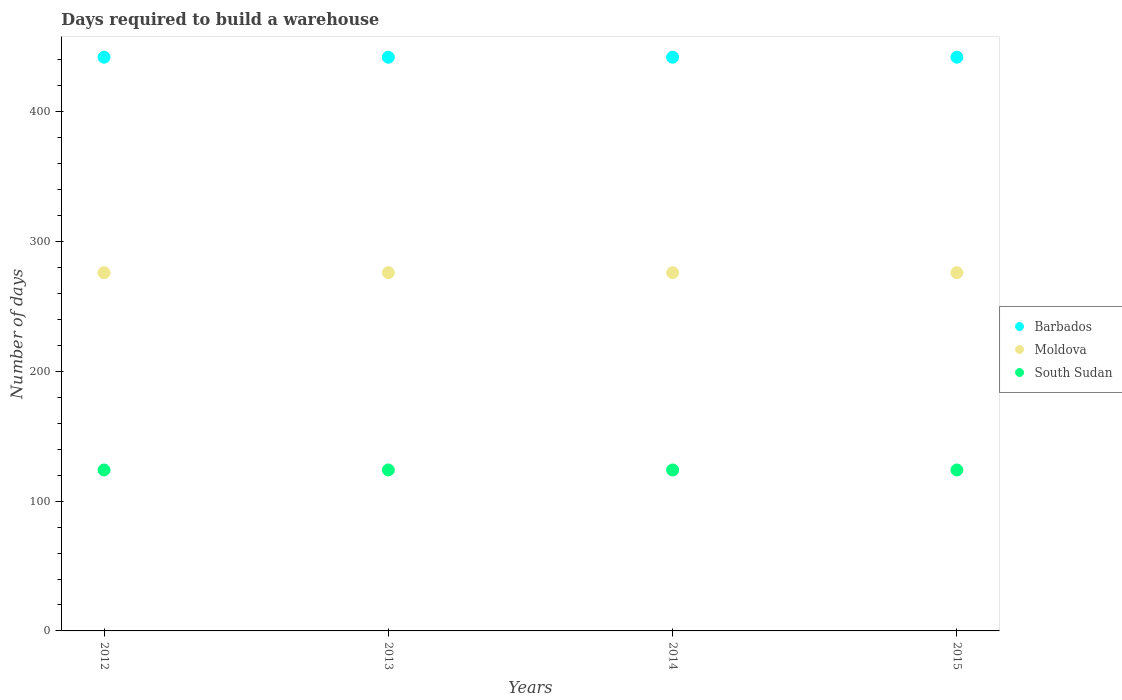What is the days required to build a warehouse in in South Sudan in 2013?
Provide a short and direct response. 124. Across all years, what is the maximum days required to build a warehouse in in Barbados?
Your answer should be very brief. 442. Across all years, what is the minimum days required to build a warehouse in in South Sudan?
Your response must be concise. 124. In which year was the days required to build a warehouse in in Barbados minimum?
Offer a terse response. 2012. What is the total days required to build a warehouse in in South Sudan in the graph?
Give a very brief answer. 496. What is the difference between the days required to build a warehouse in in Barbados in 2012 and that in 2014?
Make the answer very short. 0. What is the difference between the days required to build a warehouse in in Barbados in 2013 and the days required to build a warehouse in in Moldova in 2014?
Ensure brevity in your answer.  166. What is the average days required to build a warehouse in in Moldova per year?
Your answer should be very brief. 276. In the year 2012, what is the difference between the days required to build a warehouse in in South Sudan and days required to build a warehouse in in Moldova?
Make the answer very short. -152. In how many years, is the days required to build a warehouse in in South Sudan greater than 80 days?
Offer a terse response. 4. What is the ratio of the days required to build a warehouse in in Moldova in 2012 to that in 2014?
Offer a terse response. 1. Is the days required to build a warehouse in in Barbados in 2012 less than that in 2015?
Your answer should be compact. No. What is the difference between the highest and the second highest days required to build a warehouse in in Moldova?
Provide a short and direct response. 0. Is it the case that in every year, the sum of the days required to build a warehouse in in South Sudan and days required to build a warehouse in in Barbados  is greater than the days required to build a warehouse in in Moldova?
Make the answer very short. Yes. Is the days required to build a warehouse in in South Sudan strictly greater than the days required to build a warehouse in in Barbados over the years?
Keep it short and to the point. No. What is the difference between two consecutive major ticks on the Y-axis?
Offer a very short reply. 100. Are the values on the major ticks of Y-axis written in scientific E-notation?
Offer a very short reply. No. Where does the legend appear in the graph?
Ensure brevity in your answer.  Center right. What is the title of the graph?
Make the answer very short. Days required to build a warehouse. What is the label or title of the X-axis?
Your answer should be compact. Years. What is the label or title of the Y-axis?
Your answer should be compact. Number of days. What is the Number of days in Barbados in 2012?
Your answer should be compact. 442. What is the Number of days of Moldova in 2012?
Provide a short and direct response. 276. What is the Number of days of South Sudan in 2012?
Your answer should be compact. 124. What is the Number of days of Barbados in 2013?
Your response must be concise. 442. What is the Number of days of Moldova in 2013?
Your answer should be very brief. 276. What is the Number of days of South Sudan in 2013?
Provide a succinct answer. 124. What is the Number of days of Barbados in 2014?
Provide a short and direct response. 442. What is the Number of days of Moldova in 2014?
Make the answer very short. 276. What is the Number of days in South Sudan in 2014?
Give a very brief answer. 124. What is the Number of days in Barbados in 2015?
Your answer should be very brief. 442. What is the Number of days in Moldova in 2015?
Your response must be concise. 276. What is the Number of days in South Sudan in 2015?
Make the answer very short. 124. Across all years, what is the maximum Number of days of Barbados?
Give a very brief answer. 442. Across all years, what is the maximum Number of days in Moldova?
Provide a succinct answer. 276. Across all years, what is the maximum Number of days of South Sudan?
Provide a short and direct response. 124. Across all years, what is the minimum Number of days in Barbados?
Your answer should be very brief. 442. Across all years, what is the minimum Number of days in Moldova?
Ensure brevity in your answer.  276. Across all years, what is the minimum Number of days in South Sudan?
Make the answer very short. 124. What is the total Number of days in Barbados in the graph?
Keep it short and to the point. 1768. What is the total Number of days of Moldova in the graph?
Offer a very short reply. 1104. What is the total Number of days in South Sudan in the graph?
Provide a succinct answer. 496. What is the difference between the Number of days of South Sudan in 2012 and that in 2013?
Give a very brief answer. 0. What is the difference between the Number of days of Barbados in 2012 and that in 2014?
Give a very brief answer. 0. What is the difference between the Number of days in Barbados in 2012 and that in 2015?
Your answer should be compact. 0. What is the difference between the Number of days of South Sudan in 2012 and that in 2015?
Your answer should be compact. 0. What is the difference between the Number of days of Barbados in 2013 and that in 2014?
Make the answer very short. 0. What is the difference between the Number of days of Moldova in 2013 and that in 2014?
Offer a terse response. 0. What is the difference between the Number of days of Moldova in 2013 and that in 2015?
Make the answer very short. 0. What is the difference between the Number of days in Moldova in 2014 and that in 2015?
Your response must be concise. 0. What is the difference between the Number of days of Barbados in 2012 and the Number of days of Moldova in 2013?
Your answer should be very brief. 166. What is the difference between the Number of days of Barbados in 2012 and the Number of days of South Sudan in 2013?
Ensure brevity in your answer.  318. What is the difference between the Number of days of Moldova in 2012 and the Number of days of South Sudan in 2013?
Offer a very short reply. 152. What is the difference between the Number of days of Barbados in 2012 and the Number of days of Moldova in 2014?
Make the answer very short. 166. What is the difference between the Number of days of Barbados in 2012 and the Number of days of South Sudan in 2014?
Offer a terse response. 318. What is the difference between the Number of days of Moldova in 2012 and the Number of days of South Sudan in 2014?
Offer a very short reply. 152. What is the difference between the Number of days in Barbados in 2012 and the Number of days in Moldova in 2015?
Give a very brief answer. 166. What is the difference between the Number of days of Barbados in 2012 and the Number of days of South Sudan in 2015?
Offer a very short reply. 318. What is the difference between the Number of days in Moldova in 2012 and the Number of days in South Sudan in 2015?
Offer a terse response. 152. What is the difference between the Number of days in Barbados in 2013 and the Number of days in Moldova in 2014?
Your answer should be very brief. 166. What is the difference between the Number of days of Barbados in 2013 and the Number of days of South Sudan in 2014?
Provide a succinct answer. 318. What is the difference between the Number of days of Moldova in 2013 and the Number of days of South Sudan in 2014?
Make the answer very short. 152. What is the difference between the Number of days of Barbados in 2013 and the Number of days of Moldova in 2015?
Give a very brief answer. 166. What is the difference between the Number of days of Barbados in 2013 and the Number of days of South Sudan in 2015?
Ensure brevity in your answer.  318. What is the difference between the Number of days of Moldova in 2013 and the Number of days of South Sudan in 2015?
Provide a short and direct response. 152. What is the difference between the Number of days in Barbados in 2014 and the Number of days in Moldova in 2015?
Your response must be concise. 166. What is the difference between the Number of days in Barbados in 2014 and the Number of days in South Sudan in 2015?
Your answer should be compact. 318. What is the difference between the Number of days in Moldova in 2014 and the Number of days in South Sudan in 2015?
Give a very brief answer. 152. What is the average Number of days in Barbados per year?
Keep it short and to the point. 442. What is the average Number of days in Moldova per year?
Your answer should be very brief. 276. What is the average Number of days in South Sudan per year?
Ensure brevity in your answer.  124. In the year 2012, what is the difference between the Number of days in Barbados and Number of days in Moldova?
Provide a short and direct response. 166. In the year 2012, what is the difference between the Number of days in Barbados and Number of days in South Sudan?
Your response must be concise. 318. In the year 2012, what is the difference between the Number of days in Moldova and Number of days in South Sudan?
Your answer should be compact. 152. In the year 2013, what is the difference between the Number of days of Barbados and Number of days of Moldova?
Give a very brief answer. 166. In the year 2013, what is the difference between the Number of days of Barbados and Number of days of South Sudan?
Offer a terse response. 318. In the year 2013, what is the difference between the Number of days of Moldova and Number of days of South Sudan?
Offer a terse response. 152. In the year 2014, what is the difference between the Number of days of Barbados and Number of days of Moldova?
Ensure brevity in your answer.  166. In the year 2014, what is the difference between the Number of days of Barbados and Number of days of South Sudan?
Offer a very short reply. 318. In the year 2014, what is the difference between the Number of days of Moldova and Number of days of South Sudan?
Your response must be concise. 152. In the year 2015, what is the difference between the Number of days in Barbados and Number of days in Moldova?
Keep it short and to the point. 166. In the year 2015, what is the difference between the Number of days in Barbados and Number of days in South Sudan?
Your response must be concise. 318. In the year 2015, what is the difference between the Number of days of Moldova and Number of days of South Sudan?
Provide a succinct answer. 152. What is the ratio of the Number of days of Barbados in 2012 to that in 2013?
Your answer should be very brief. 1. What is the ratio of the Number of days in Moldova in 2012 to that in 2013?
Keep it short and to the point. 1. What is the ratio of the Number of days of Moldova in 2012 to that in 2014?
Your answer should be compact. 1. What is the ratio of the Number of days in Moldova in 2013 to that in 2014?
Provide a short and direct response. 1. What is the ratio of the Number of days in South Sudan in 2013 to that in 2014?
Give a very brief answer. 1. What is the ratio of the Number of days of Moldova in 2013 to that in 2015?
Provide a short and direct response. 1. What is the ratio of the Number of days in Barbados in 2014 to that in 2015?
Your response must be concise. 1. What is the ratio of the Number of days in South Sudan in 2014 to that in 2015?
Your response must be concise. 1. What is the difference between the highest and the second highest Number of days of Barbados?
Give a very brief answer. 0. What is the difference between the highest and the lowest Number of days of Barbados?
Provide a succinct answer. 0. What is the difference between the highest and the lowest Number of days of South Sudan?
Ensure brevity in your answer.  0. 